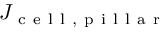Convert formula to latex. <formula><loc_0><loc_0><loc_500><loc_500>J _ { c e l l , p i l l a r }</formula> 